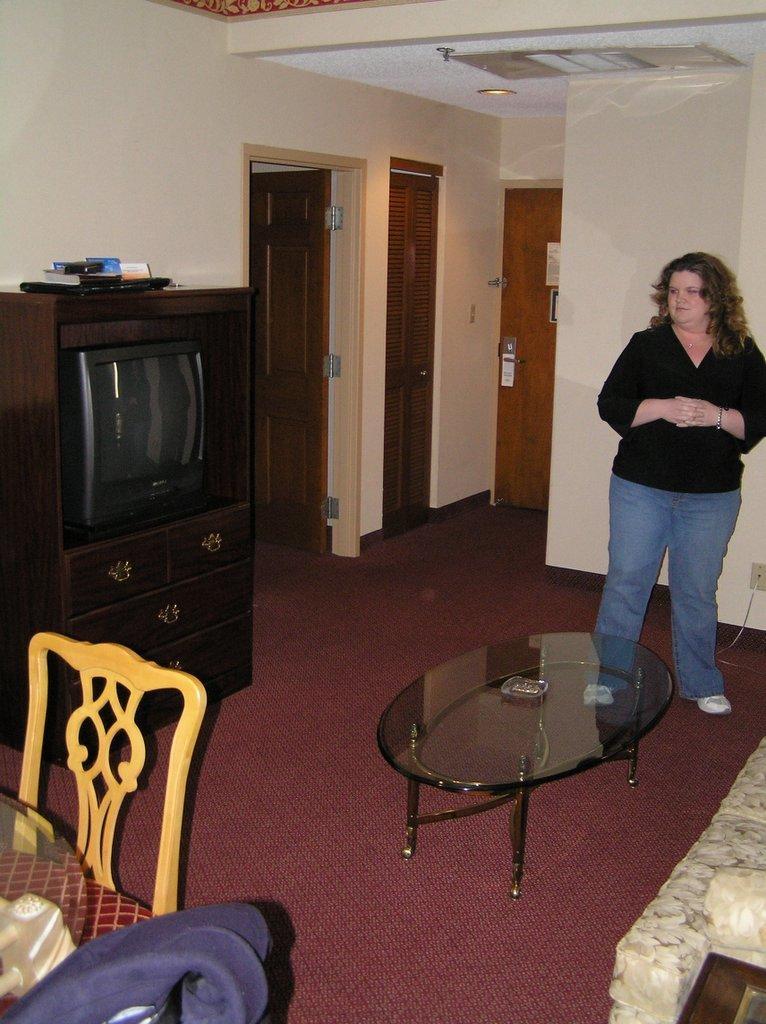How would you summarize this image in a sentence or two? In this picture we can see woman standing and in front of her there is table and bedside to her we can see sofa, cupboard, doors and here chair and table. 